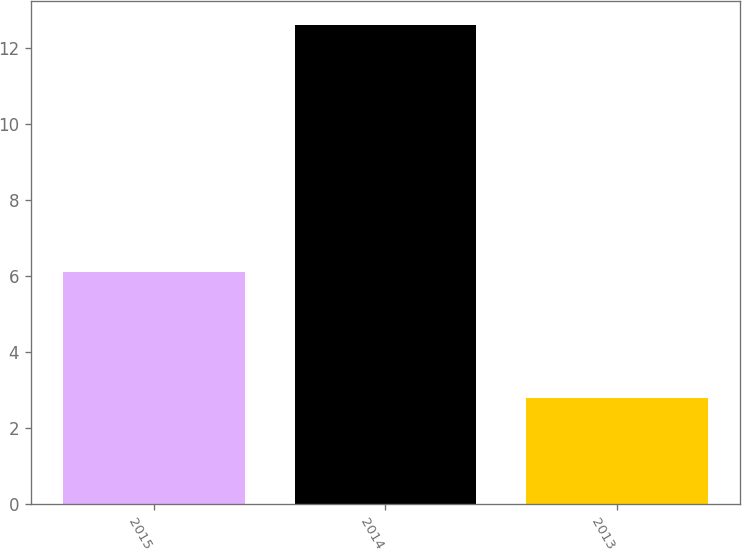Convert chart. <chart><loc_0><loc_0><loc_500><loc_500><bar_chart><fcel>2015<fcel>2014<fcel>2013<nl><fcel>6.1<fcel>12.6<fcel>2.8<nl></chart> 